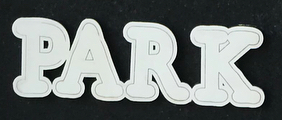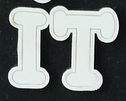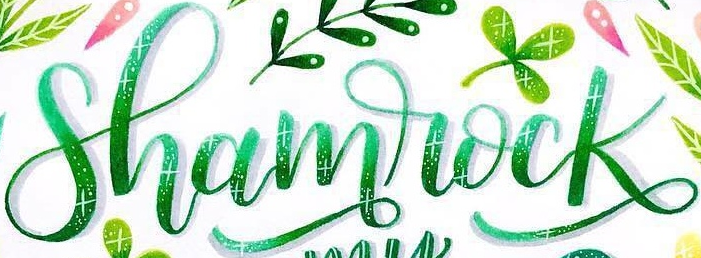What words are shown in these images in order, separated by a semicolon? PARK; IT; Shamrock 